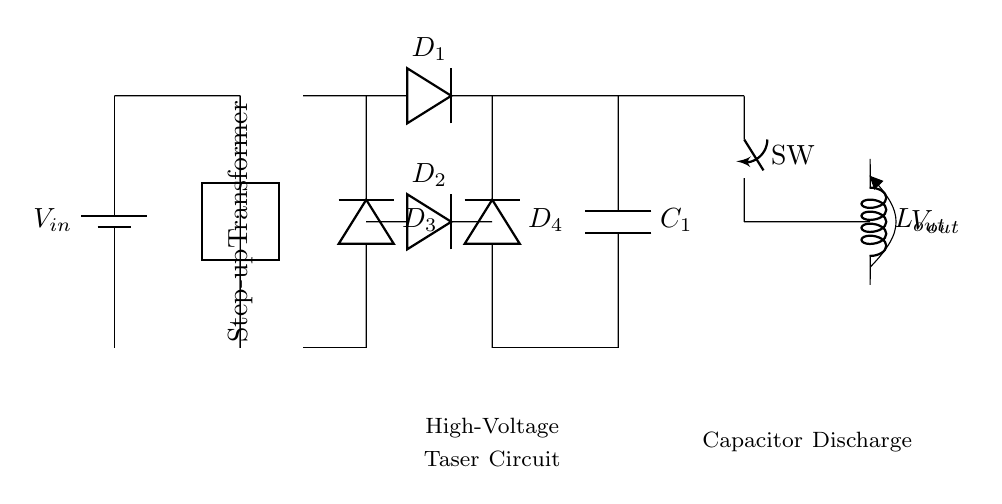What is the input voltage of this circuit? The input voltage is marked as V_in in the battery symbol, indicating it supplies the circuit.
Answer: V_in What component is used to increase the voltage? The step-up transformer is specifically designed to increase the voltage from the input to a higher output.
Answer: Step-up Transformer How many diodes are in the rectifier? There are four diodes in the circuit, labeled D1, D2, D3, and D4, in the rectifier section.
Answer: 4 What is the role of the capacitor in this circuit? The capacitor (C1) serves to store the electrical energy and discharges it when the switch (SW) is activated.
Answer: Store energy What happens when the switch is closed? Closing the switch allows the stored energy in the capacitor to discharge through the output electrodes, delivering a high-voltage output.
Answer: Discharges What type of output is generated from this circuit? The output generated is a high-voltage pulse that results from the capacitor discharging when the switch is activated, intended for non-lethal applications.
Answer: High-voltage pulse Which component prevents backward current flow? The diodes (D1, D2, D3, D4) prevent backward current flow by allowing current to travel in only one direction during the rectification process.
Answer: Diodes 